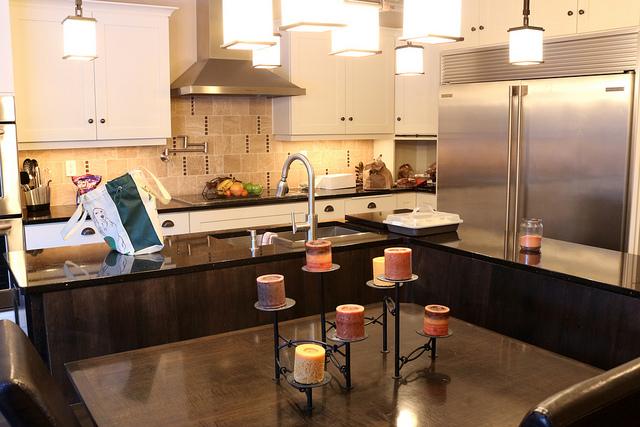Are the candles on the table lit?
Answer briefly. No. What is the color of the fridge?
Answer briefly. Silver. Is this a modern kitchen?
Concise answer only. Yes. Is there a coffee maker?
Give a very brief answer. No. What kind of counter surfaces is this?
Write a very short answer. Marble. 